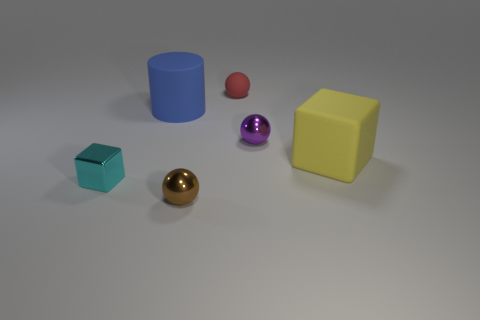Subtract all small brown shiny spheres. How many spheres are left? 2 Subtract all purple balls. How many balls are left? 2 Subtract all cylinders. How many objects are left? 5 Subtract 1 cylinders. How many cylinders are left? 0 Subtract all gray cylinders. How many brown balls are left? 1 Subtract all metallic spheres. Subtract all tiny brown spheres. How many objects are left? 3 Add 5 big things. How many big things are left? 7 Add 2 blocks. How many blocks exist? 4 Add 2 small cylinders. How many objects exist? 8 Subtract 0 cyan spheres. How many objects are left? 6 